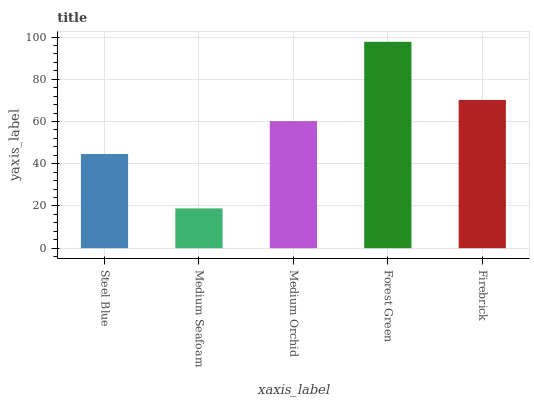Is Medium Seafoam the minimum?
Answer yes or no. Yes. Is Forest Green the maximum?
Answer yes or no. Yes. Is Medium Orchid the minimum?
Answer yes or no. No. Is Medium Orchid the maximum?
Answer yes or no. No. Is Medium Orchid greater than Medium Seafoam?
Answer yes or no. Yes. Is Medium Seafoam less than Medium Orchid?
Answer yes or no. Yes. Is Medium Seafoam greater than Medium Orchid?
Answer yes or no. No. Is Medium Orchid less than Medium Seafoam?
Answer yes or no. No. Is Medium Orchid the high median?
Answer yes or no. Yes. Is Medium Orchid the low median?
Answer yes or no. Yes. Is Steel Blue the high median?
Answer yes or no. No. Is Medium Seafoam the low median?
Answer yes or no. No. 